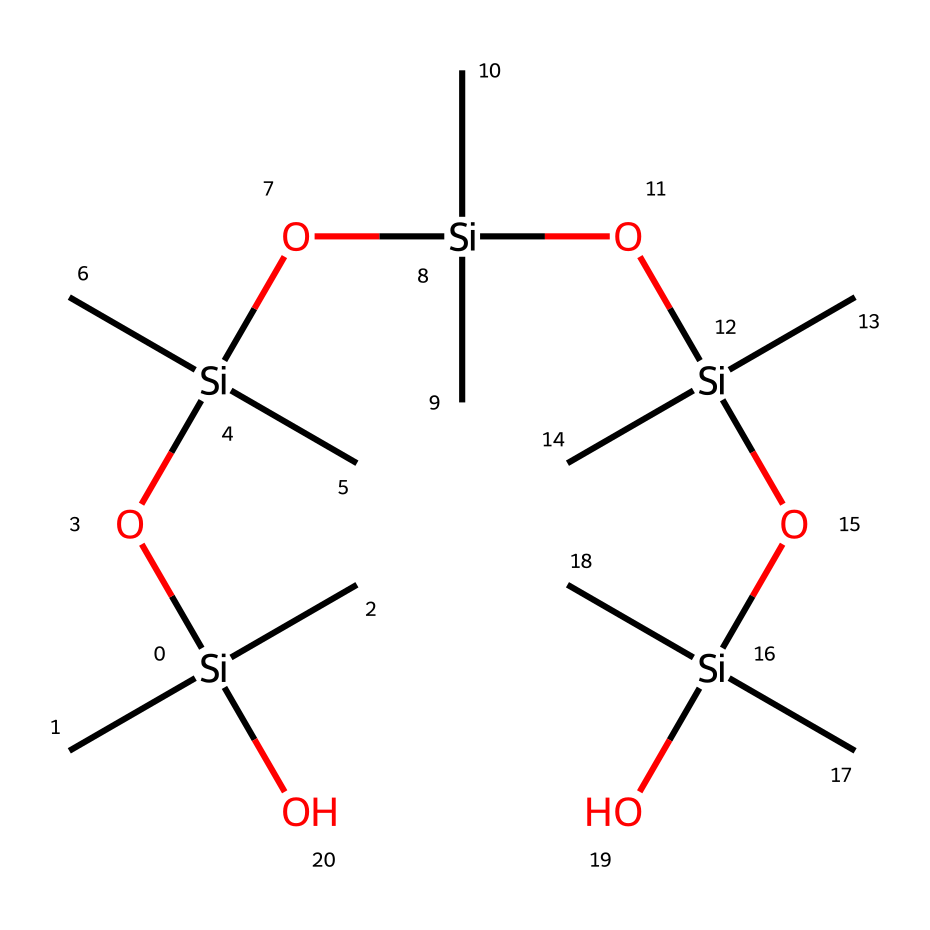What element is primarily responsible for the silicone's structure? The structure is largely made up of silicon atoms, which are represented by the letters "Si" in the SMILES notation. This indicates that silicon is the backbone of the compound.
Answer: silicon How many hydroxyl groups are present in this chemical structure? The presence of "O" indicates hydroxyl groups; in the given SMILES, there are five instances of "O" linked to silicon, which represent five hydroxyl groups.
Answer: five What is the total number of silicon atoms in this compound? By counting the occurrences of "Si" in the SMILES representation, we find that it appears six times, thus there are six silicon atoms.
Answer: six What type of bond connects the silicon and oxygen atoms in this structure? The presence of silicon linked to oxygen in a chain arrangement suggests that these are silicon-oxygen bonds, which are characteristic of siloxane linkages.
Answer: siloxane Does this compound include carbon atoms, and if so, how many? The "C" represents carbon atoms in the structure, and by counting the "C" occurrences next to each silicon, we find there are twelve carbon atoms total in the structure.
Answer: twelve What functional groups are present in this silicone-based product? The repeating unit of the structure indicates that the primary functional group is hydroxyl groups connected to silicon, representing silanol groups, which provide the hair smoothing properties.
Answer: silanol How does the structure of this compound contribute to its smoothening properties for hair? The alternating silicon and oxygen atoms create a flexible and hydrophobic surface that reduces frizz and enhances shine when applied to hair.
Answer: hydrophobic surface 